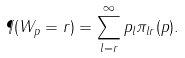Convert formula to latex. <formula><loc_0><loc_0><loc_500><loc_500>\P ( W _ { p } = r ) = \sum _ { l = r } ^ { \infty } p _ { l } \pi _ { l r } ( p ) .</formula> 